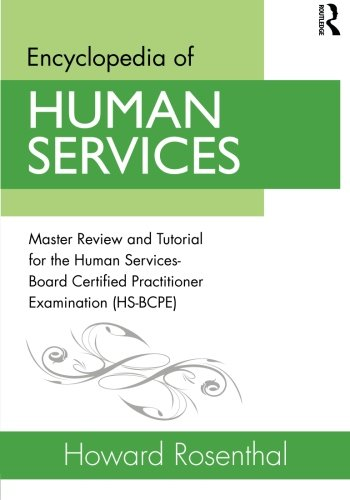Who wrote this book?
Answer the question using a single word or phrase. Howard Rosenthal What is the title of this book? Encyclopedia of Human Services: Master Review and Tutorial for the Human Services-Board Certified Practitioner Examination (HS-BCPE) What is the genre of this book? Politics & Social Sciences Is this book related to Politics & Social Sciences? Yes Is this book related to Science & Math? No 